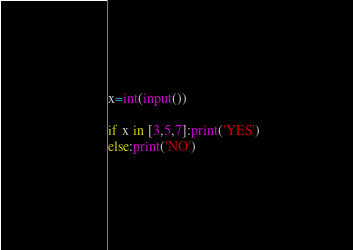Convert code to text. <code><loc_0><loc_0><loc_500><loc_500><_Python_>
x=int(input())

if x in [3,5,7]:print('YES')
else:print('NO')</code> 